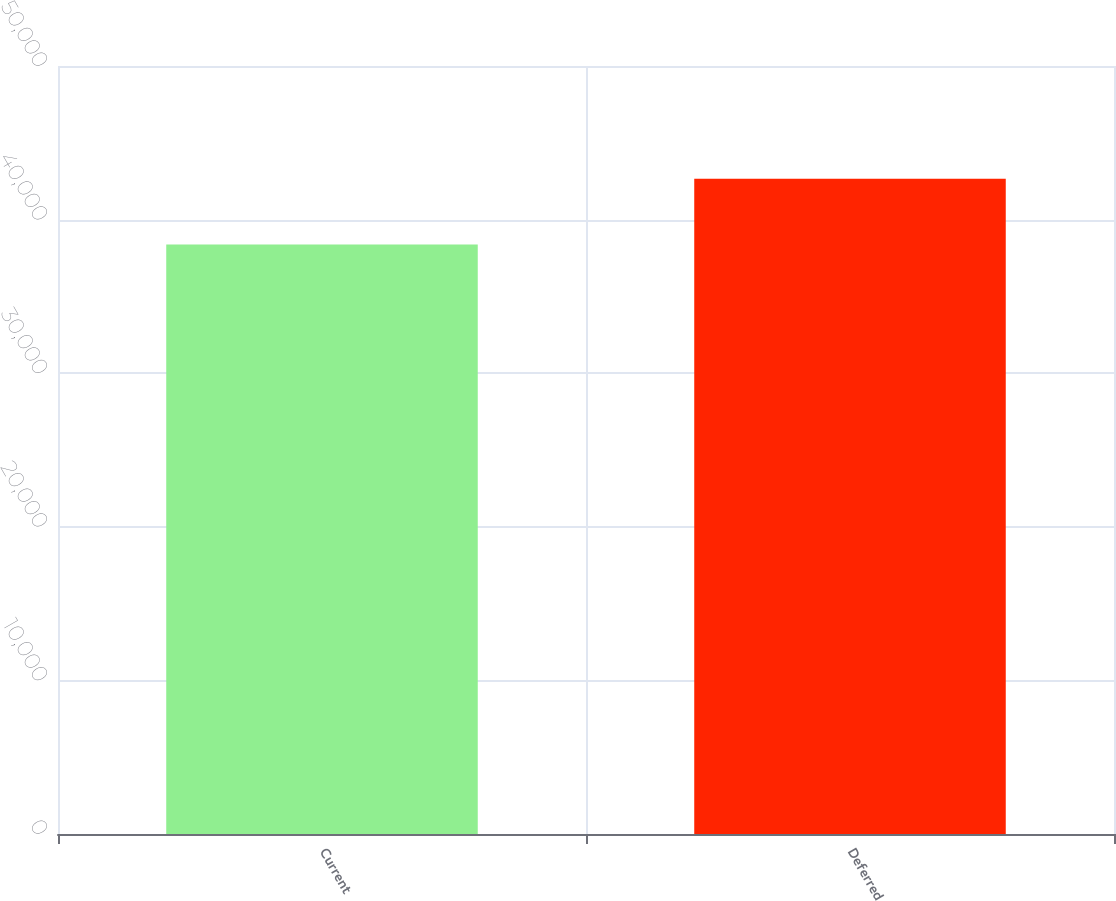Convert chart to OTSL. <chart><loc_0><loc_0><loc_500><loc_500><bar_chart><fcel>Current<fcel>Deferred<nl><fcel>38377<fcel>42660<nl></chart> 